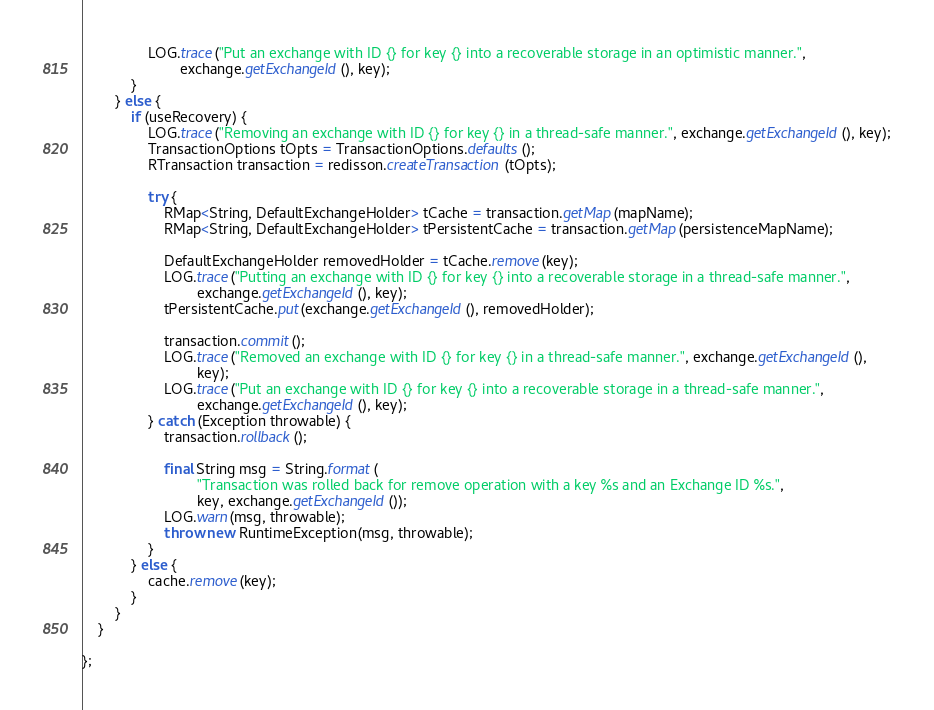Convert code to text. <code><loc_0><loc_0><loc_500><loc_500><_Java_>                LOG.trace("Put an exchange with ID {} for key {} into a recoverable storage in an optimistic manner.",
                        exchange.getExchangeId(), key);
            }
        } else {
            if (useRecovery) {
                LOG.trace("Removing an exchange with ID {} for key {} in a thread-safe manner.", exchange.getExchangeId(), key);
                TransactionOptions tOpts = TransactionOptions.defaults();
                RTransaction transaction = redisson.createTransaction(tOpts);

                try {
                    RMap<String, DefaultExchangeHolder> tCache = transaction.getMap(mapName);
                    RMap<String, DefaultExchangeHolder> tPersistentCache = transaction.getMap(persistenceMapName);

                    DefaultExchangeHolder removedHolder = tCache.remove(key);
                    LOG.trace("Putting an exchange with ID {} for key {} into a recoverable storage in a thread-safe manner.",
                            exchange.getExchangeId(), key);
                    tPersistentCache.put(exchange.getExchangeId(), removedHolder);

                    transaction.commit();
                    LOG.trace("Removed an exchange with ID {} for key {} in a thread-safe manner.", exchange.getExchangeId(),
                            key);
                    LOG.trace("Put an exchange with ID {} for key {} into a recoverable storage in a thread-safe manner.",
                            exchange.getExchangeId(), key);
                } catch (Exception throwable) {
                    transaction.rollback();

                    final String msg = String.format(
                            "Transaction was rolled back for remove operation with a key %s and an Exchange ID %s.",
                            key, exchange.getExchangeId());
                    LOG.warn(msg, throwable);
                    throw new RuntimeException(msg, throwable);
                }
            } else {
                cache.remove(key);
            }
        }
    }

};</code> 